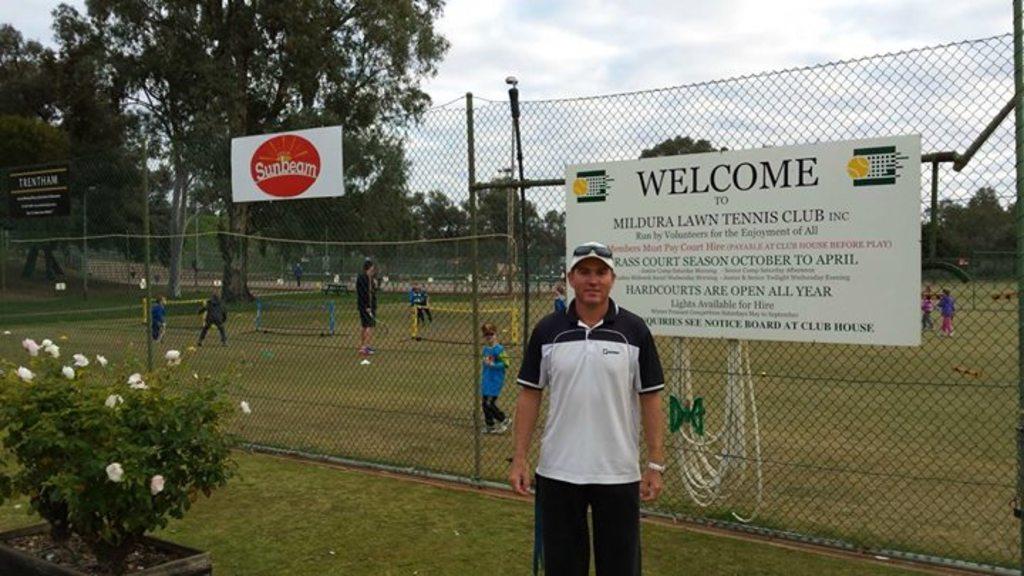When are hardcourts open?
Ensure brevity in your answer.  All year. What kind of sign is he in front of?
Provide a short and direct response. Welcome sign. 